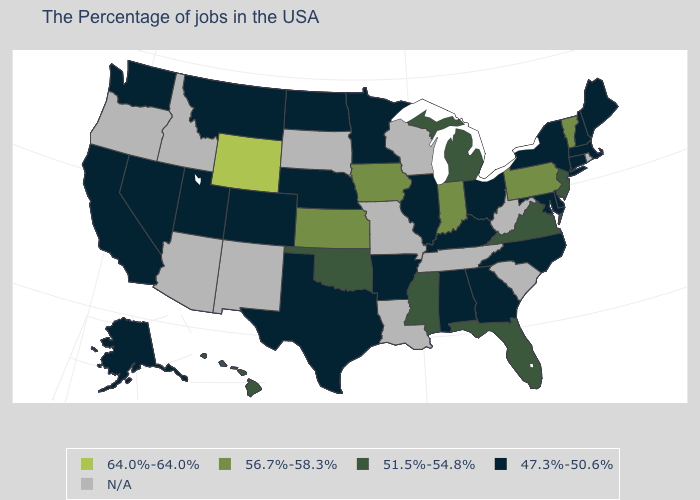What is the value of Maryland?
Be succinct. 47.3%-50.6%. Name the states that have a value in the range 47.3%-50.6%?
Quick response, please. Maine, Massachusetts, New Hampshire, Connecticut, New York, Delaware, Maryland, North Carolina, Ohio, Georgia, Kentucky, Alabama, Illinois, Arkansas, Minnesota, Nebraska, Texas, North Dakota, Colorado, Utah, Montana, Nevada, California, Washington, Alaska. Name the states that have a value in the range 51.5%-54.8%?
Answer briefly. New Jersey, Virginia, Florida, Michigan, Mississippi, Oklahoma, Hawaii. Name the states that have a value in the range 47.3%-50.6%?
Give a very brief answer. Maine, Massachusetts, New Hampshire, Connecticut, New York, Delaware, Maryland, North Carolina, Ohio, Georgia, Kentucky, Alabama, Illinois, Arkansas, Minnesota, Nebraska, Texas, North Dakota, Colorado, Utah, Montana, Nevada, California, Washington, Alaska. Does New Jersey have the highest value in the Northeast?
Concise answer only. No. Which states have the highest value in the USA?
Keep it brief. Wyoming. What is the value of New Hampshire?
Concise answer only. 47.3%-50.6%. Name the states that have a value in the range 64.0%-64.0%?
Write a very short answer. Wyoming. Name the states that have a value in the range 47.3%-50.6%?
Short answer required. Maine, Massachusetts, New Hampshire, Connecticut, New York, Delaware, Maryland, North Carolina, Ohio, Georgia, Kentucky, Alabama, Illinois, Arkansas, Minnesota, Nebraska, Texas, North Dakota, Colorado, Utah, Montana, Nevada, California, Washington, Alaska. Which states have the highest value in the USA?
Short answer required. Wyoming. Among the states that border Nebraska , which have the highest value?
Be succinct. Wyoming. Which states have the highest value in the USA?
Be succinct. Wyoming. Name the states that have a value in the range 47.3%-50.6%?
Keep it brief. Maine, Massachusetts, New Hampshire, Connecticut, New York, Delaware, Maryland, North Carolina, Ohio, Georgia, Kentucky, Alabama, Illinois, Arkansas, Minnesota, Nebraska, Texas, North Dakota, Colorado, Utah, Montana, Nevada, California, Washington, Alaska. 